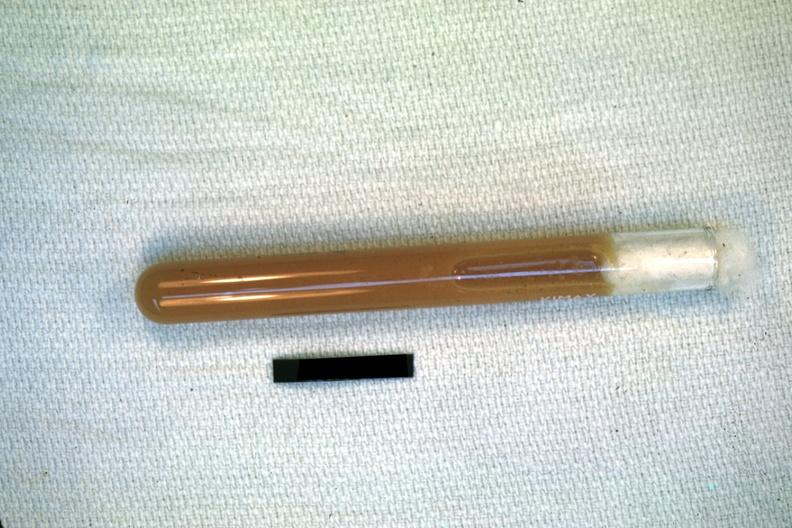what does case of peritonitis slide illustrate?
Answer the question using a single word or phrase. Pus from the peritoneal cavity 